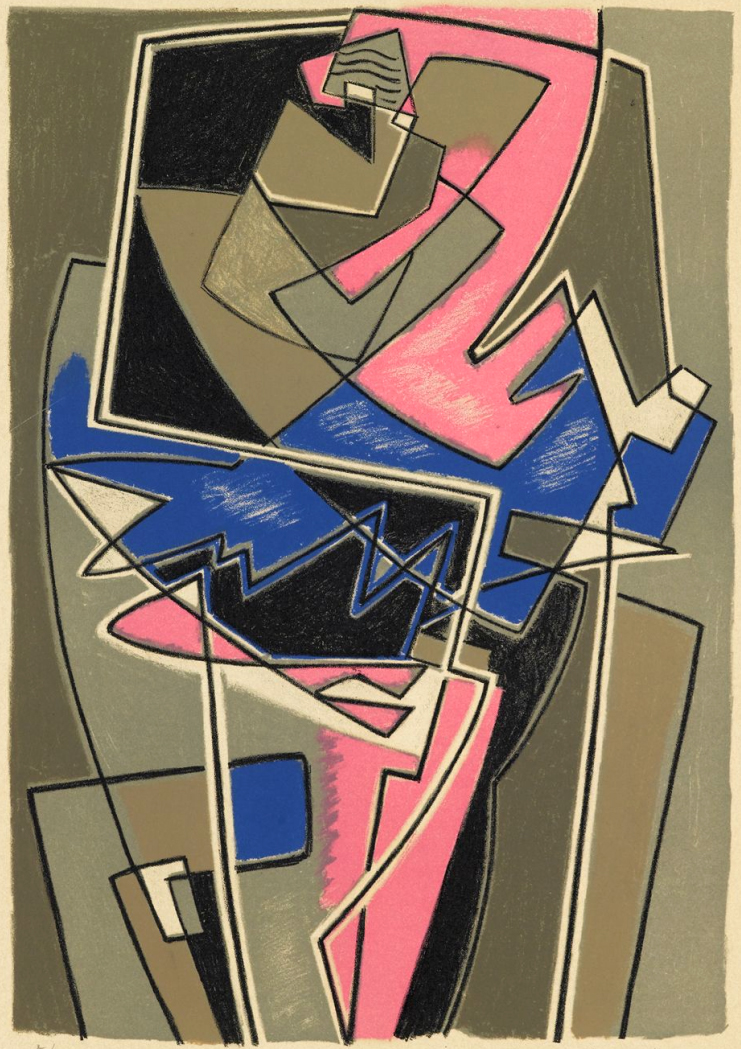Can you tell more about the significance of colors used in this cubist painting? Certainly! In this cubist painting, the use of distinctive colors like pink, blue, and black primarily aids in breaking the norms of naturalistic coloration, typical for the style. The pink and blue add contrasts that energize the piece, possibly invoking emotions or representing specific themes like passion or serenity. Black and gray provide grounding, creating depth and helping to define and separate the geometric planes, enhancing the three-dimensional illusion within the two-dimensional space. 